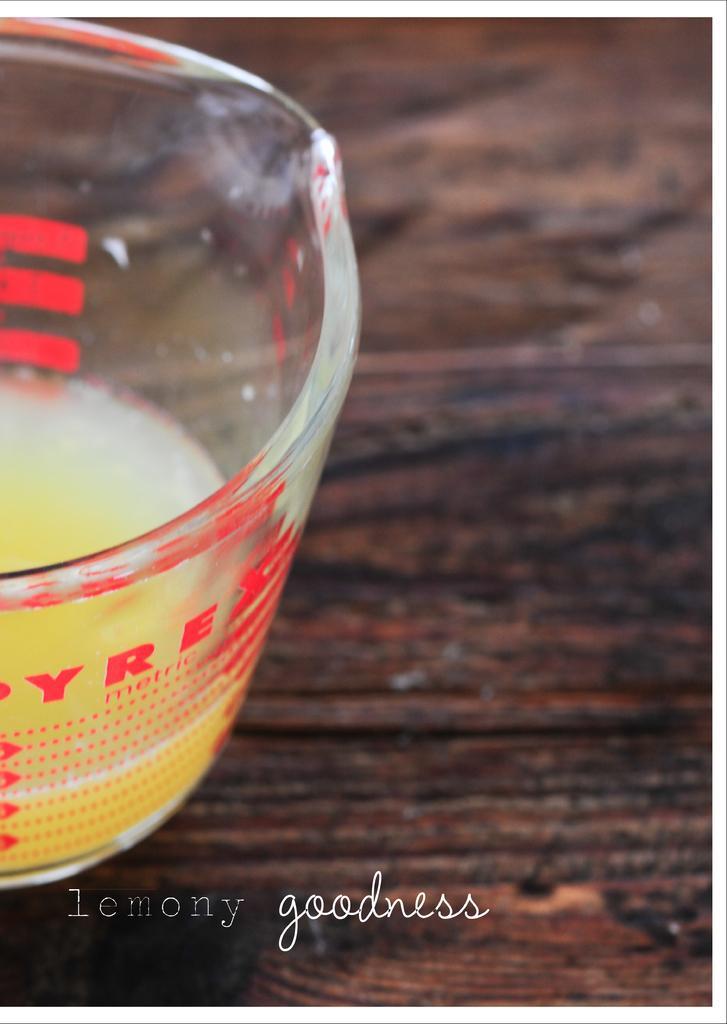Could you give a brief overview of what you see in this image? Here in this picture we can see a glass of juice present on the table over there. 